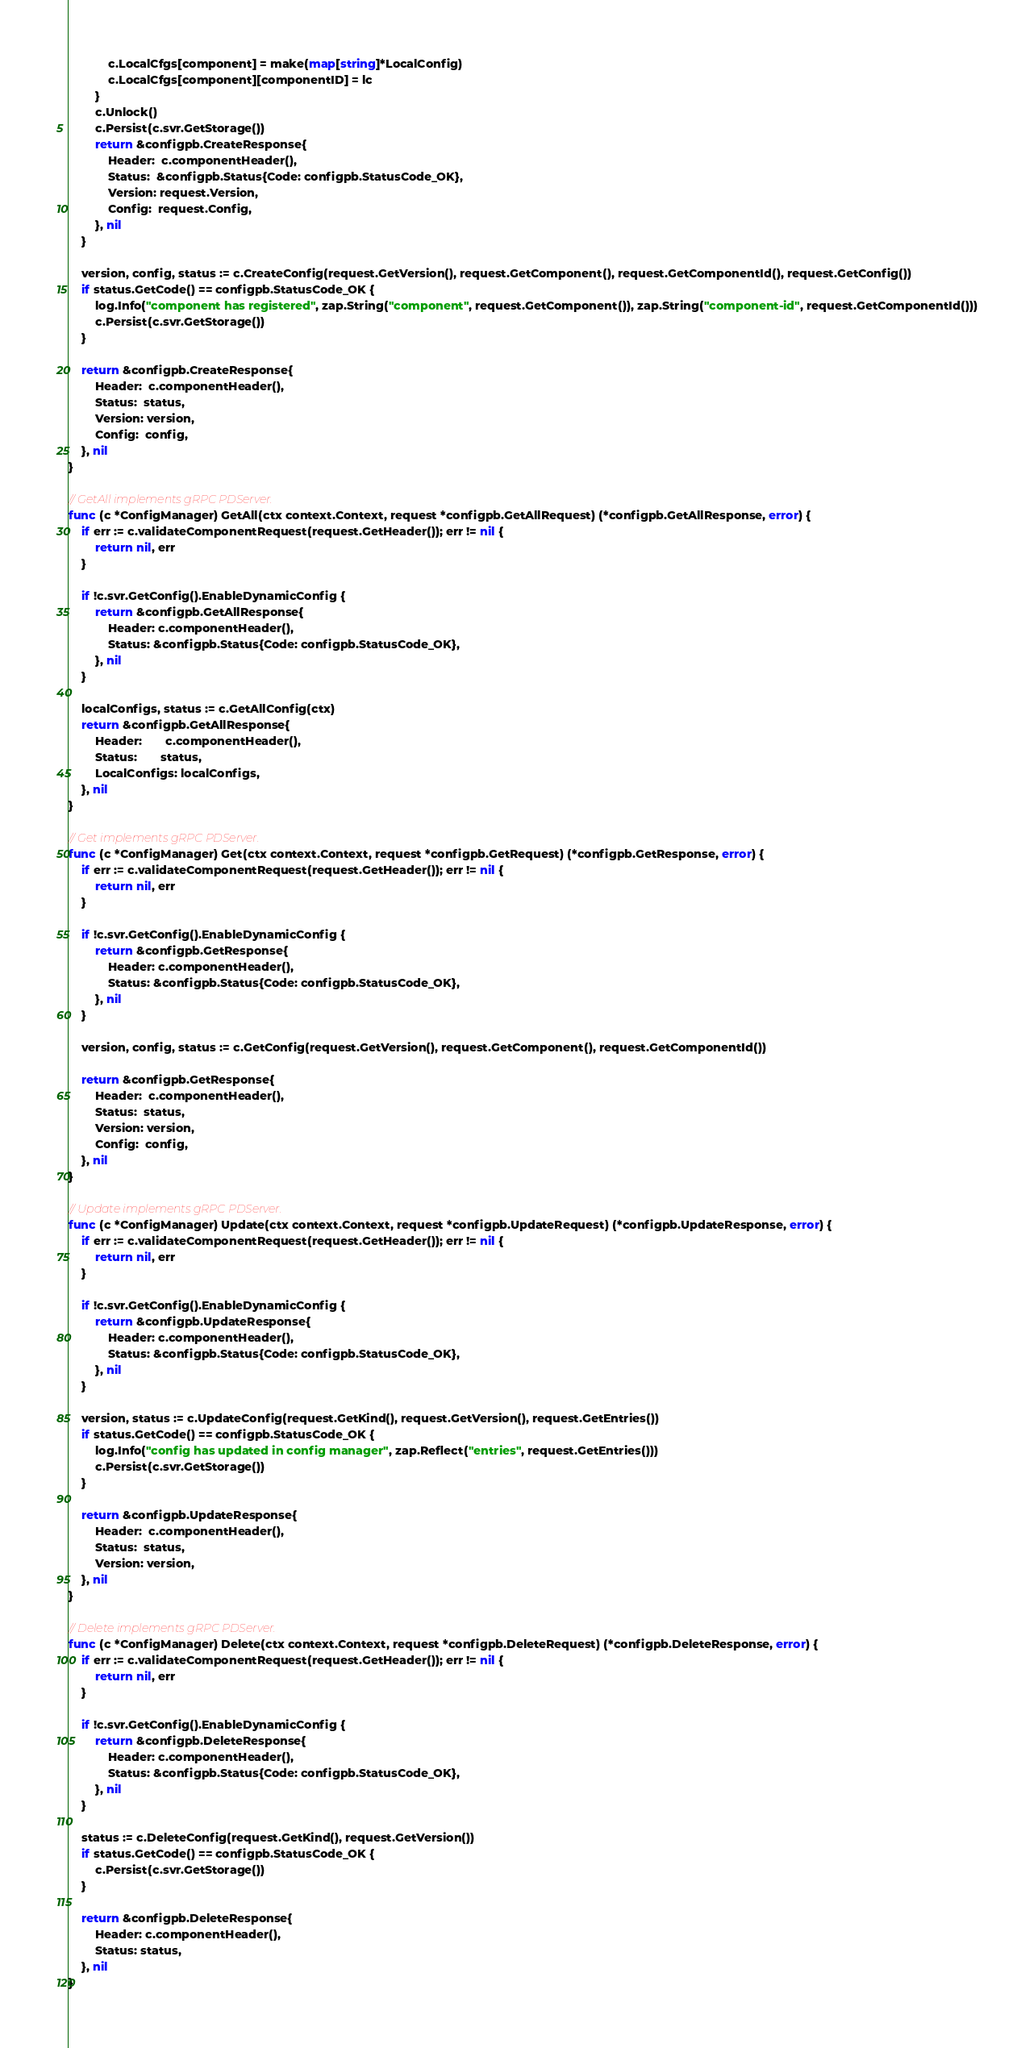<code> <loc_0><loc_0><loc_500><loc_500><_Go_>			c.LocalCfgs[component] = make(map[string]*LocalConfig)
			c.LocalCfgs[component][componentID] = lc
		}
		c.Unlock()
		c.Persist(c.svr.GetStorage())
		return &configpb.CreateResponse{
			Header:  c.componentHeader(),
			Status:  &configpb.Status{Code: configpb.StatusCode_OK},
			Version: request.Version,
			Config:  request.Config,
		}, nil
	}

	version, config, status := c.CreateConfig(request.GetVersion(), request.GetComponent(), request.GetComponentId(), request.GetConfig())
	if status.GetCode() == configpb.StatusCode_OK {
		log.Info("component has registered", zap.String("component", request.GetComponent()), zap.String("component-id", request.GetComponentId()))
		c.Persist(c.svr.GetStorage())
	}

	return &configpb.CreateResponse{
		Header:  c.componentHeader(),
		Status:  status,
		Version: version,
		Config:  config,
	}, nil
}

// GetAll implements gRPC PDServer.
func (c *ConfigManager) GetAll(ctx context.Context, request *configpb.GetAllRequest) (*configpb.GetAllResponse, error) {
	if err := c.validateComponentRequest(request.GetHeader()); err != nil {
		return nil, err
	}

	if !c.svr.GetConfig().EnableDynamicConfig {
		return &configpb.GetAllResponse{
			Header: c.componentHeader(),
			Status: &configpb.Status{Code: configpb.StatusCode_OK},
		}, nil
	}

	localConfigs, status := c.GetAllConfig(ctx)
	return &configpb.GetAllResponse{
		Header:       c.componentHeader(),
		Status:       status,
		LocalConfigs: localConfigs,
	}, nil
}

// Get implements gRPC PDServer.
func (c *ConfigManager) Get(ctx context.Context, request *configpb.GetRequest) (*configpb.GetResponse, error) {
	if err := c.validateComponentRequest(request.GetHeader()); err != nil {
		return nil, err
	}

	if !c.svr.GetConfig().EnableDynamicConfig {
		return &configpb.GetResponse{
			Header: c.componentHeader(),
			Status: &configpb.Status{Code: configpb.StatusCode_OK},
		}, nil
	}

	version, config, status := c.GetConfig(request.GetVersion(), request.GetComponent(), request.GetComponentId())

	return &configpb.GetResponse{
		Header:  c.componentHeader(),
		Status:  status,
		Version: version,
		Config:  config,
	}, nil
}

// Update implements gRPC PDServer.
func (c *ConfigManager) Update(ctx context.Context, request *configpb.UpdateRequest) (*configpb.UpdateResponse, error) {
	if err := c.validateComponentRequest(request.GetHeader()); err != nil {
		return nil, err
	}

	if !c.svr.GetConfig().EnableDynamicConfig {
		return &configpb.UpdateResponse{
			Header: c.componentHeader(),
			Status: &configpb.Status{Code: configpb.StatusCode_OK},
		}, nil
	}

	version, status := c.UpdateConfig(request.GetKind(), request.GetVersion(), request.GetEntries())
	if status.GetCode() == configpb.StatusCode_OK {
		log.Info("config has updated in config manager", zap.Reflect("entries", request.GetEntries()))
		c.Persist(c.svr.GetStorage())
	}

	return &configpb.UpdateResponse{
		Header:  c.componentHeader(),
		Status:  status,
		Version: version,
	}, nil
}

// Delete implements gRPC PDServer.
func (c *ConfigManager) Delete(ctx context.Context, request *configpb.DeleteRequest) (*configpb.DeleteResponse, error) {
	if err := c.validateComponentRequest(request.GetHeader()); err != nil {
		return nil, err
	}

	if !c.svr.GetConfig().EnableDynamicConfig {
		return &configpb.DeleteResponse{
			Header: c.componentHeader(),
			Status: &configpb.Status{Code: configpb.StatusCode_OK},
		}, nil
	}

	status := c.DeleteConfig(request.GetKind(), request.GetVersion())
	if status.GetCode() == configpb.StatusCode_OK {
		c.Persist(c.svr.GetStorage())
	}

	return &configpb.DeleteResponse{
		Header: c.componentHeader(),
		Status: status,
	}, nil
}
</code> 